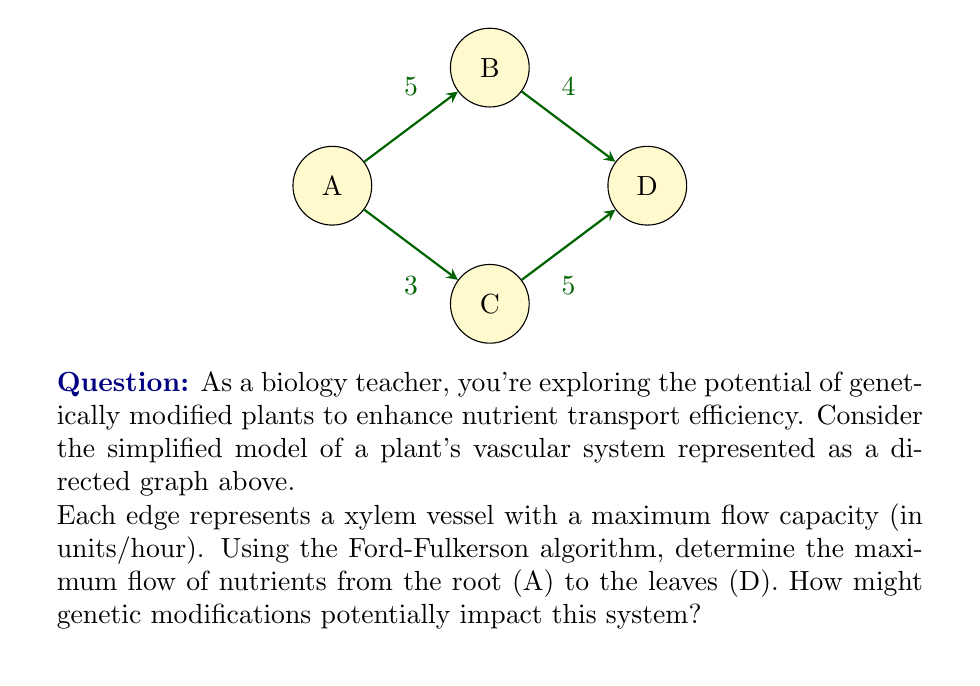Could you help me with this problem? Let's solve this step-by-step using the Ford-Fulkerson algorithm:

1) Initialize flow to 0 for all edges.

2) Find an augmenting path from A to D:
   Path 1: A → B → D (min capacity = 4)
   Flow becomes:
   A → B: 4
   B → D: 4
   Max flow = 4

3) Find another augmenting path:
   Path 2: A → C → D (min capacity = 3)
   Flow becomes:
   A → B: 4, A → C: 3
   B → D: 4, C → D: 3
   Max flow = 4 + 3 = 7

4) No more augmenting paths exist, so the algorithm terminates.

The maximum flow is 7 units/hour.

Mathematically, we can express the flow conservation constraint at each node:

For node B: $f_{AB} = f_{BD}$
For node C: $f_{AC} = f_{CD}$
For node D: $f_{BD} + f_{CD} = f_{total}$

Where $f_{ij}$ represents the flow from node i to node j.

Genetic modifications could potentially impact this system by:
1) Increasing the capacity of xylem vessels
2) Creating more efficient branching patterns
3) Enhancing root absorption capabilities

These modifications could lead to a higher maximum flow, potentially increasing nutrient transport efficiency and overall plant productivity.
Answer: 7 units/hour 